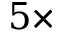Convert formula to latex. <formula><loc_0><loc_0><loc_500><loc_500>5 \times</formula> 